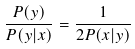<formula> <loc_0><loc_0><loc_500><loc_500>\frac { P ( y ) } { P ( y | x ) } = \frac { 1 } { 2 P ( x | y ) } \,</formula> 